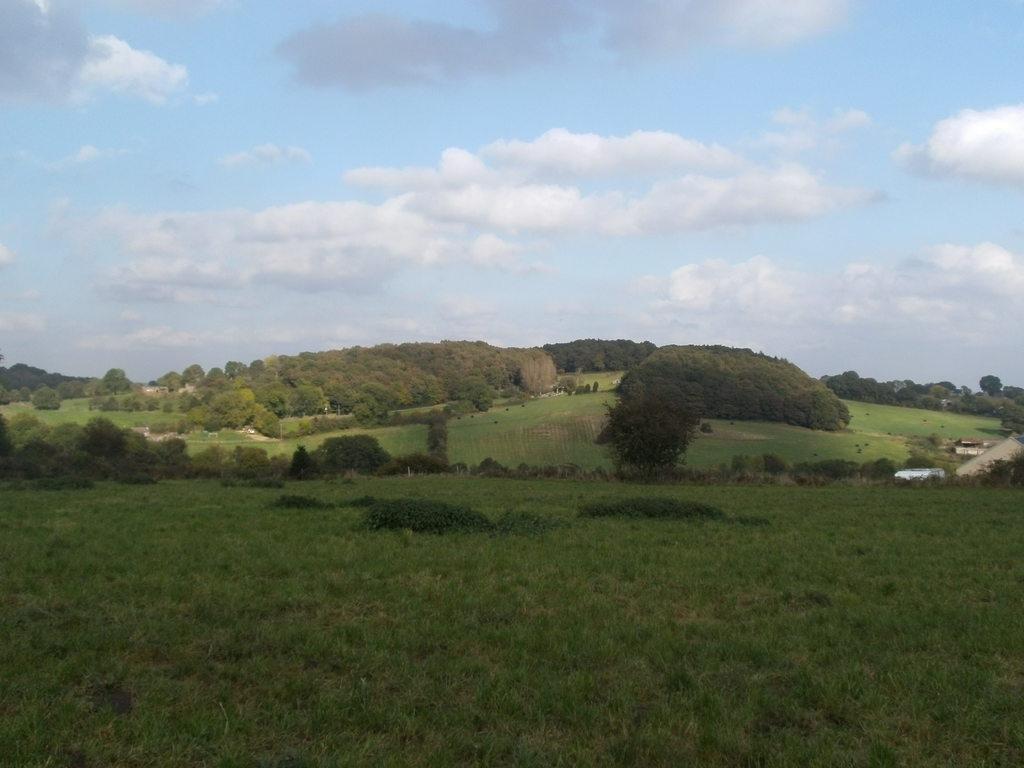Can you describe this image briefly? In this image we can see few trees, grass, plants and the sky with clouds on the top. 